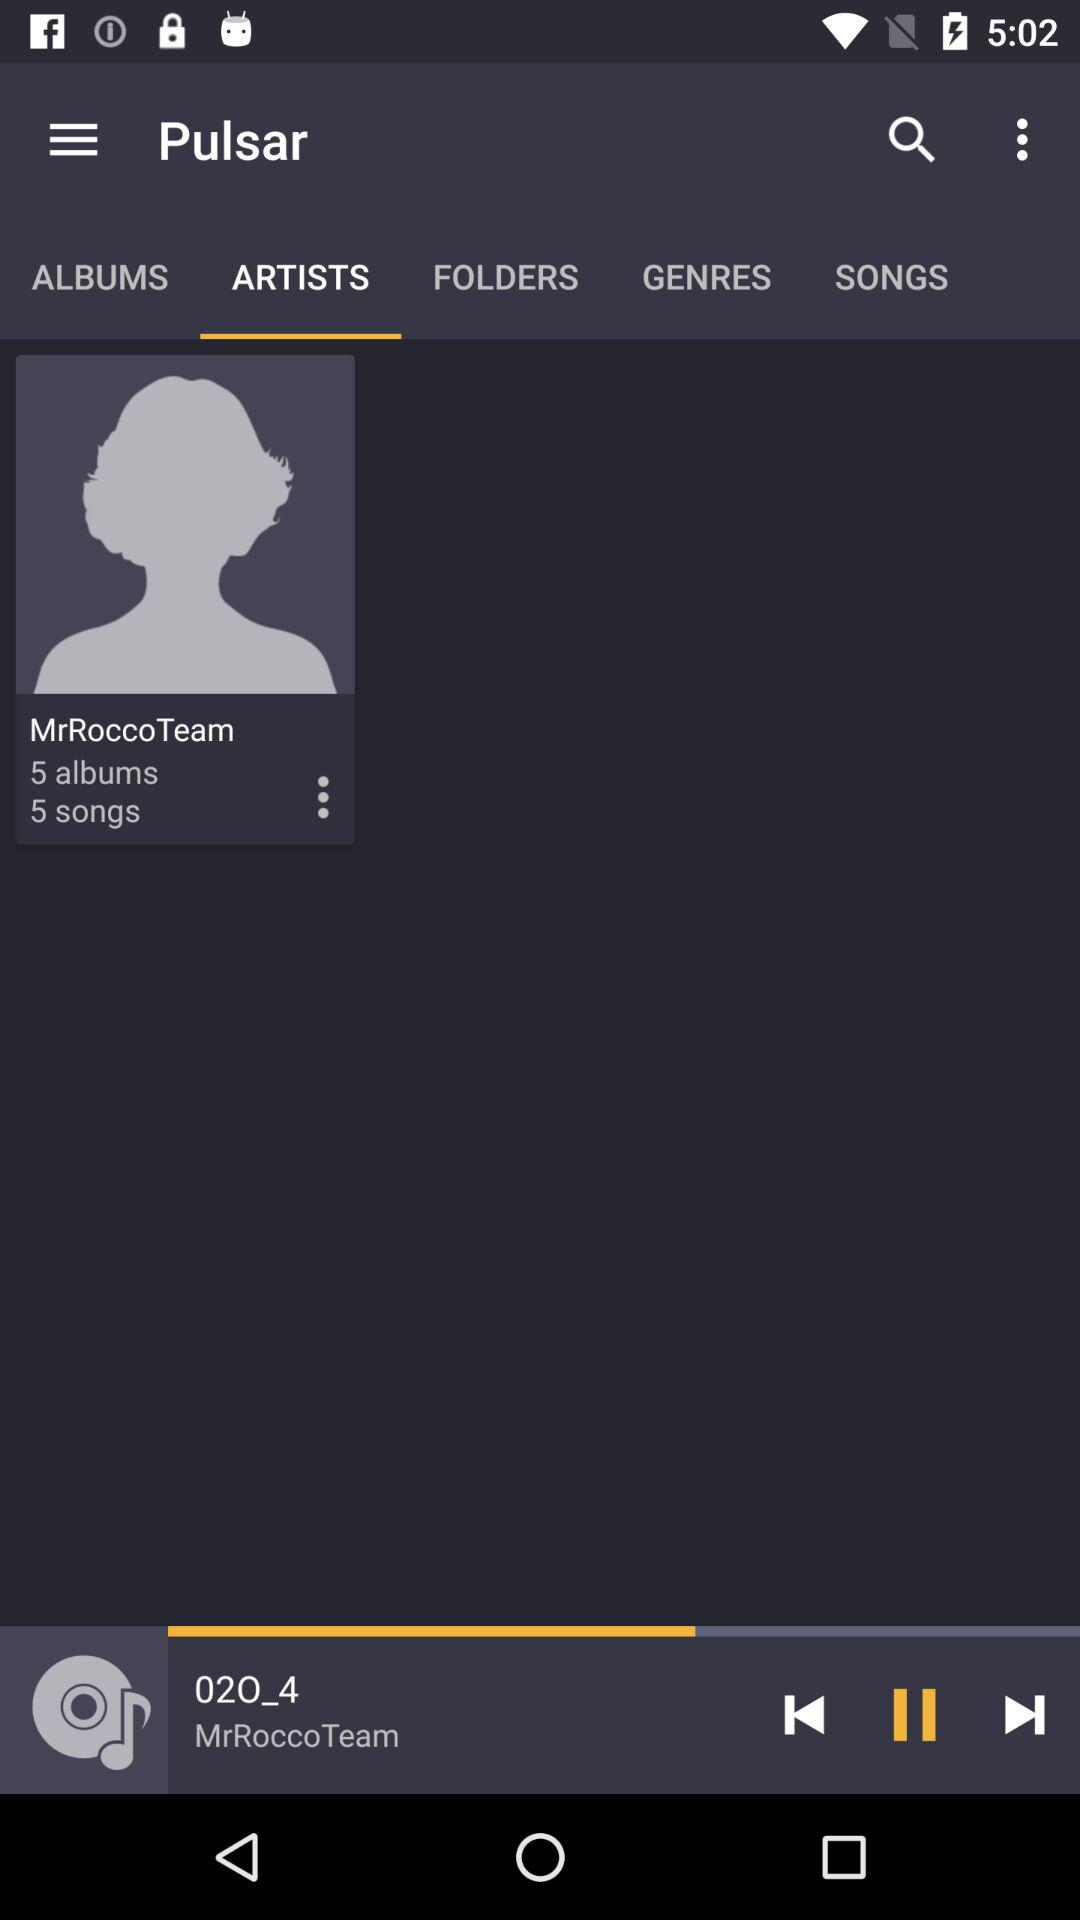How many albums are there in "MrRoccoTeam"? There are 5 albums. 